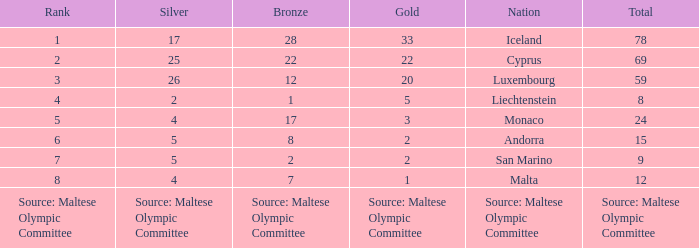How many bronze medals does the nation ranked number 1 have? 28.0. 